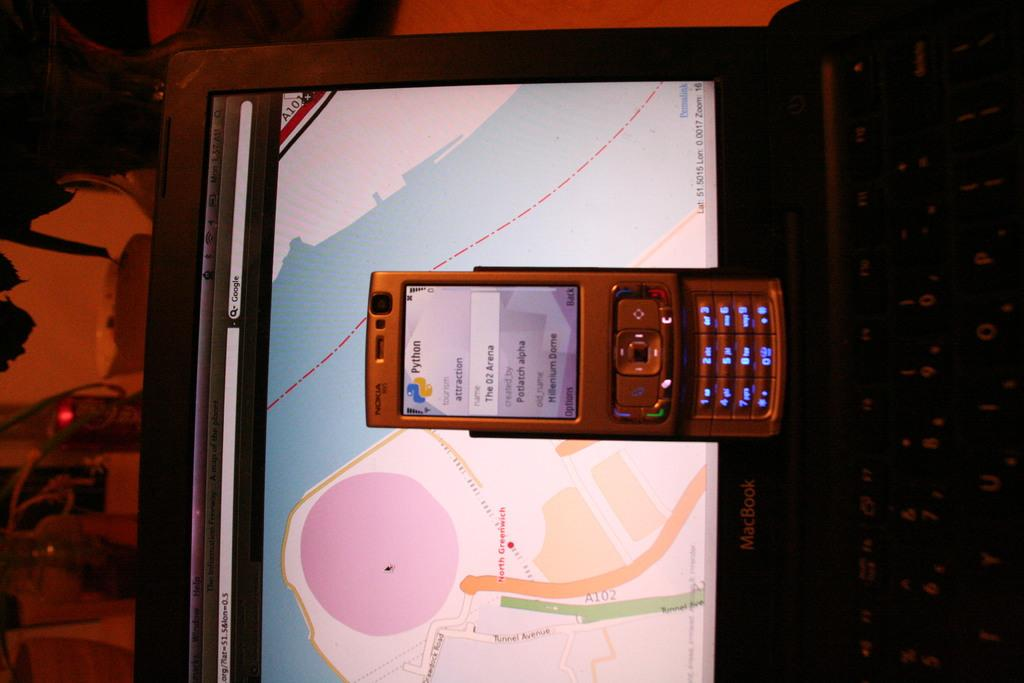<image>
Provide a brief description of the given image. A nokia phone rests on a MacBook laptop. 